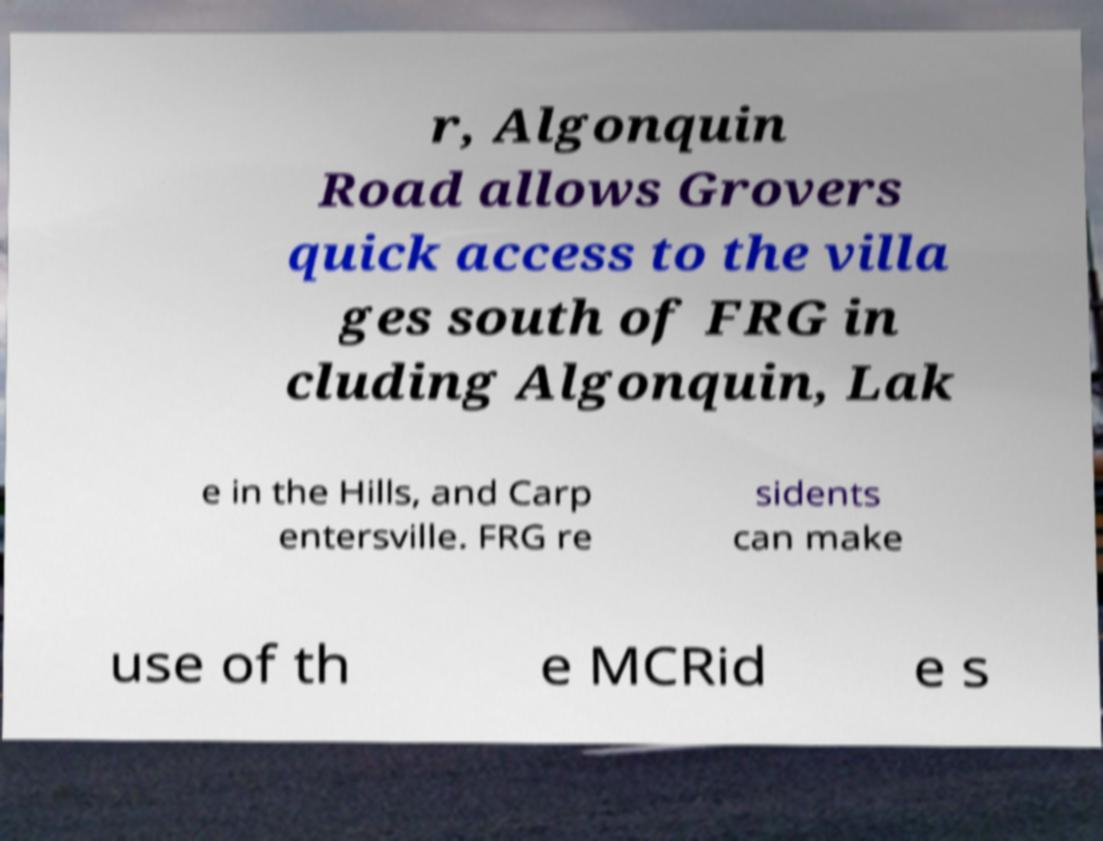There's text embedded in this image that I need extracted. Can you transcribe it verbatim? r, Algonquin Road allows Grovers quick access to the villa ges south of FRG in cluding Algonquin, Lak e in the Hills, and Carp entersville. FRG re sidents can make use of th e MCRid e s 